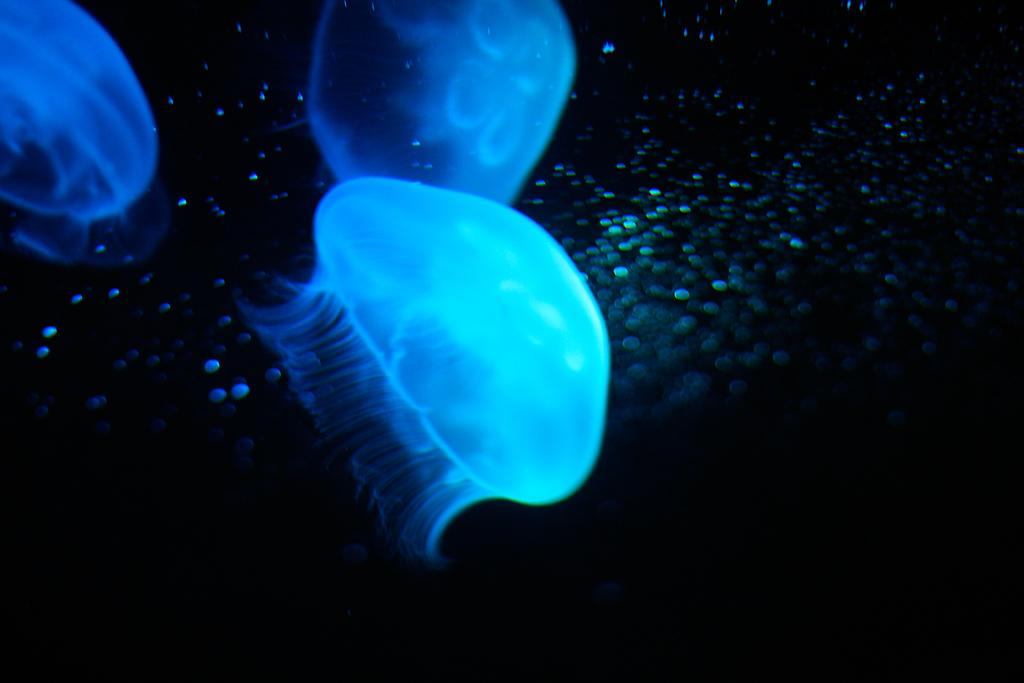What is located in the center of the image? There are objects in the center of the image. What can be seen in the background of the image? There are tiny particles in the background of the image. What is the color of the background in the image? The background of the image is black in color. What type of plastic is used to create the music in the image? There is no plastic or music present in the image; it only features objects in the center and tiny particles in the black background. 